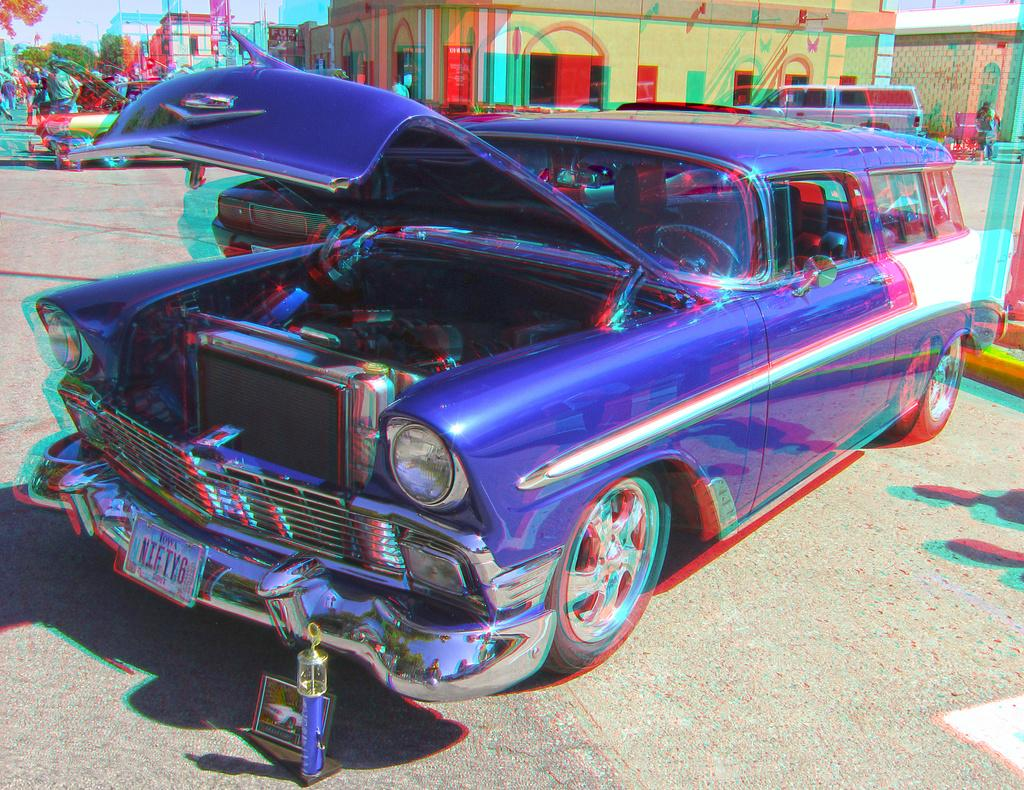Who or what can be seen in the image? There are people in the image. What else is present in the image besides people? There are vehicles, buildings, trees, and objects visible in the image. Can you describe the ground in the image? The ground is visible in the image. What is visible in the background of the image? The sky is visible in the image. What type of vacation is the judge planning based on the image? There is no judge or mention of a vacation in the image. 